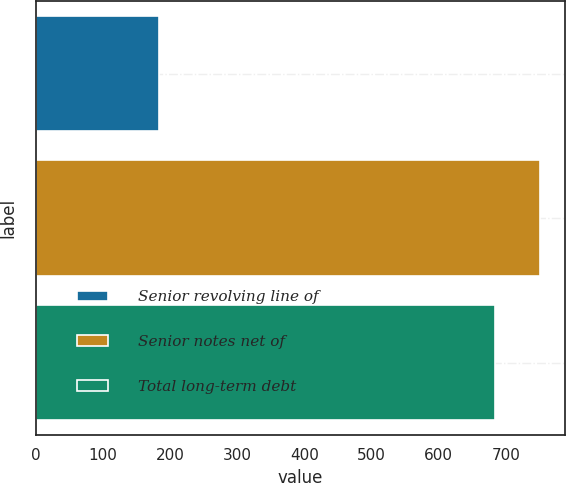Convert chart to OTSL. <chart><loc_0><loc_0><loc_500><loc_500><bar_chart><fcel>Senior revolving line of<fcel>Senior notes net of<fcel>Total long-term debt<nl><fcel>183<fcel>750.5<fcel>683.5<nl></chart> 